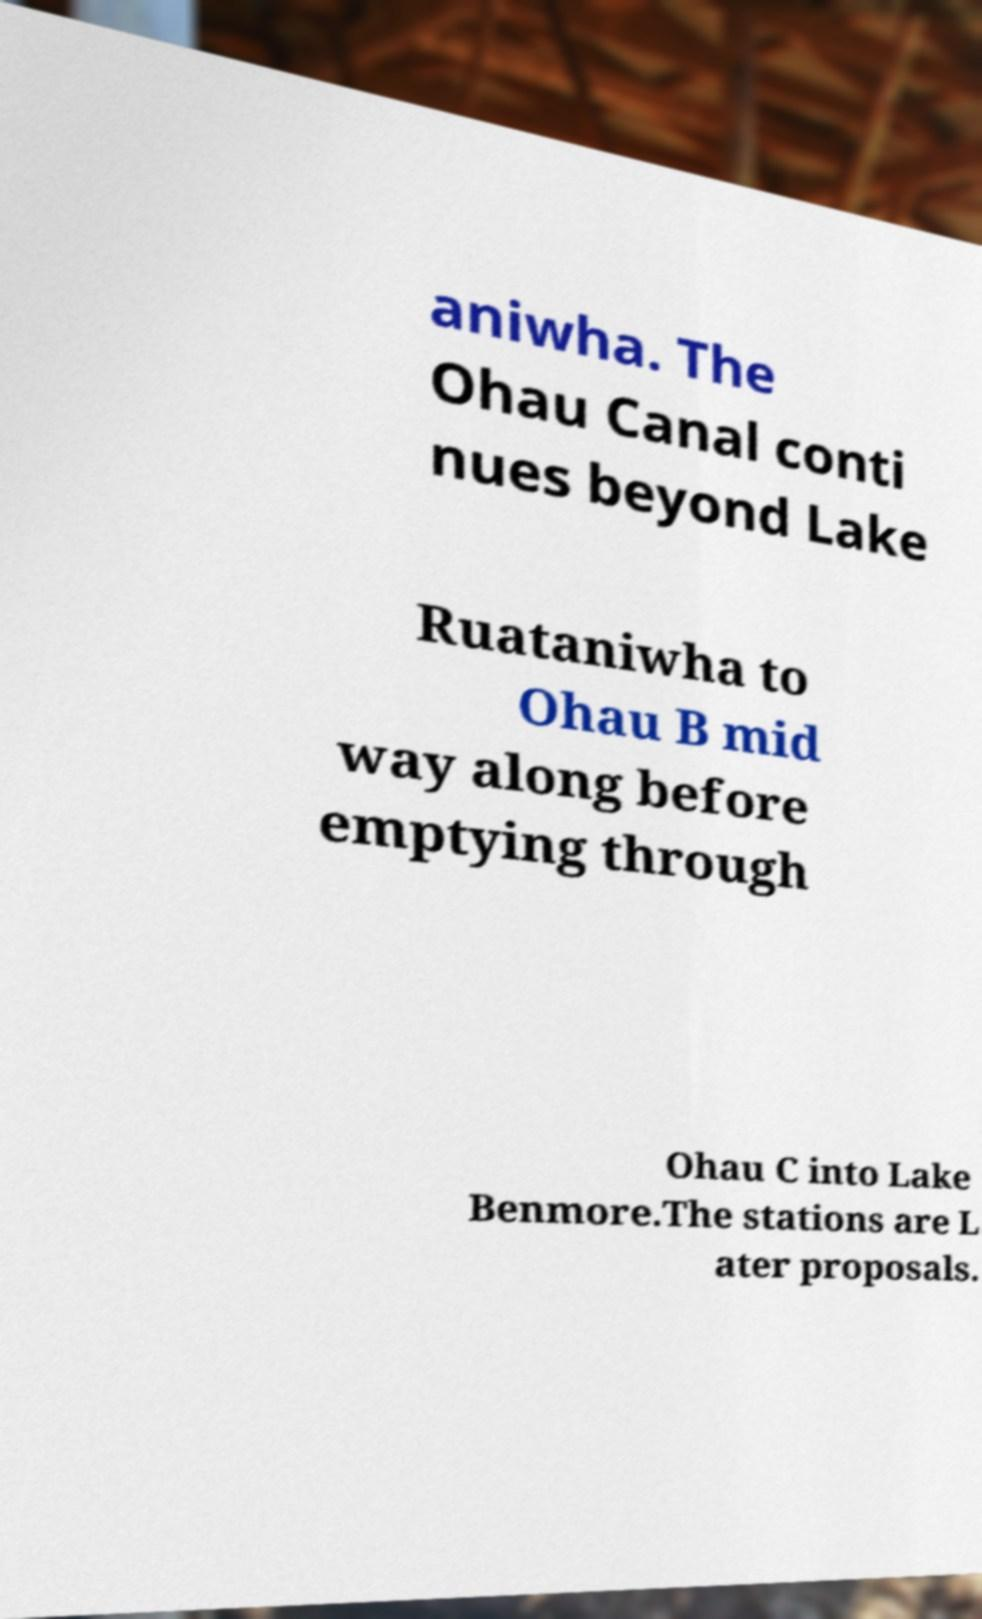I need the written content from this picture converted into text. Can you do that? aniwha. The Ohau Canal conti nues beyond Lake Ruataniwha to Ohau B mid way along before emptying through Ohau C into Lake Benmore.The stations are L ater proposals. 